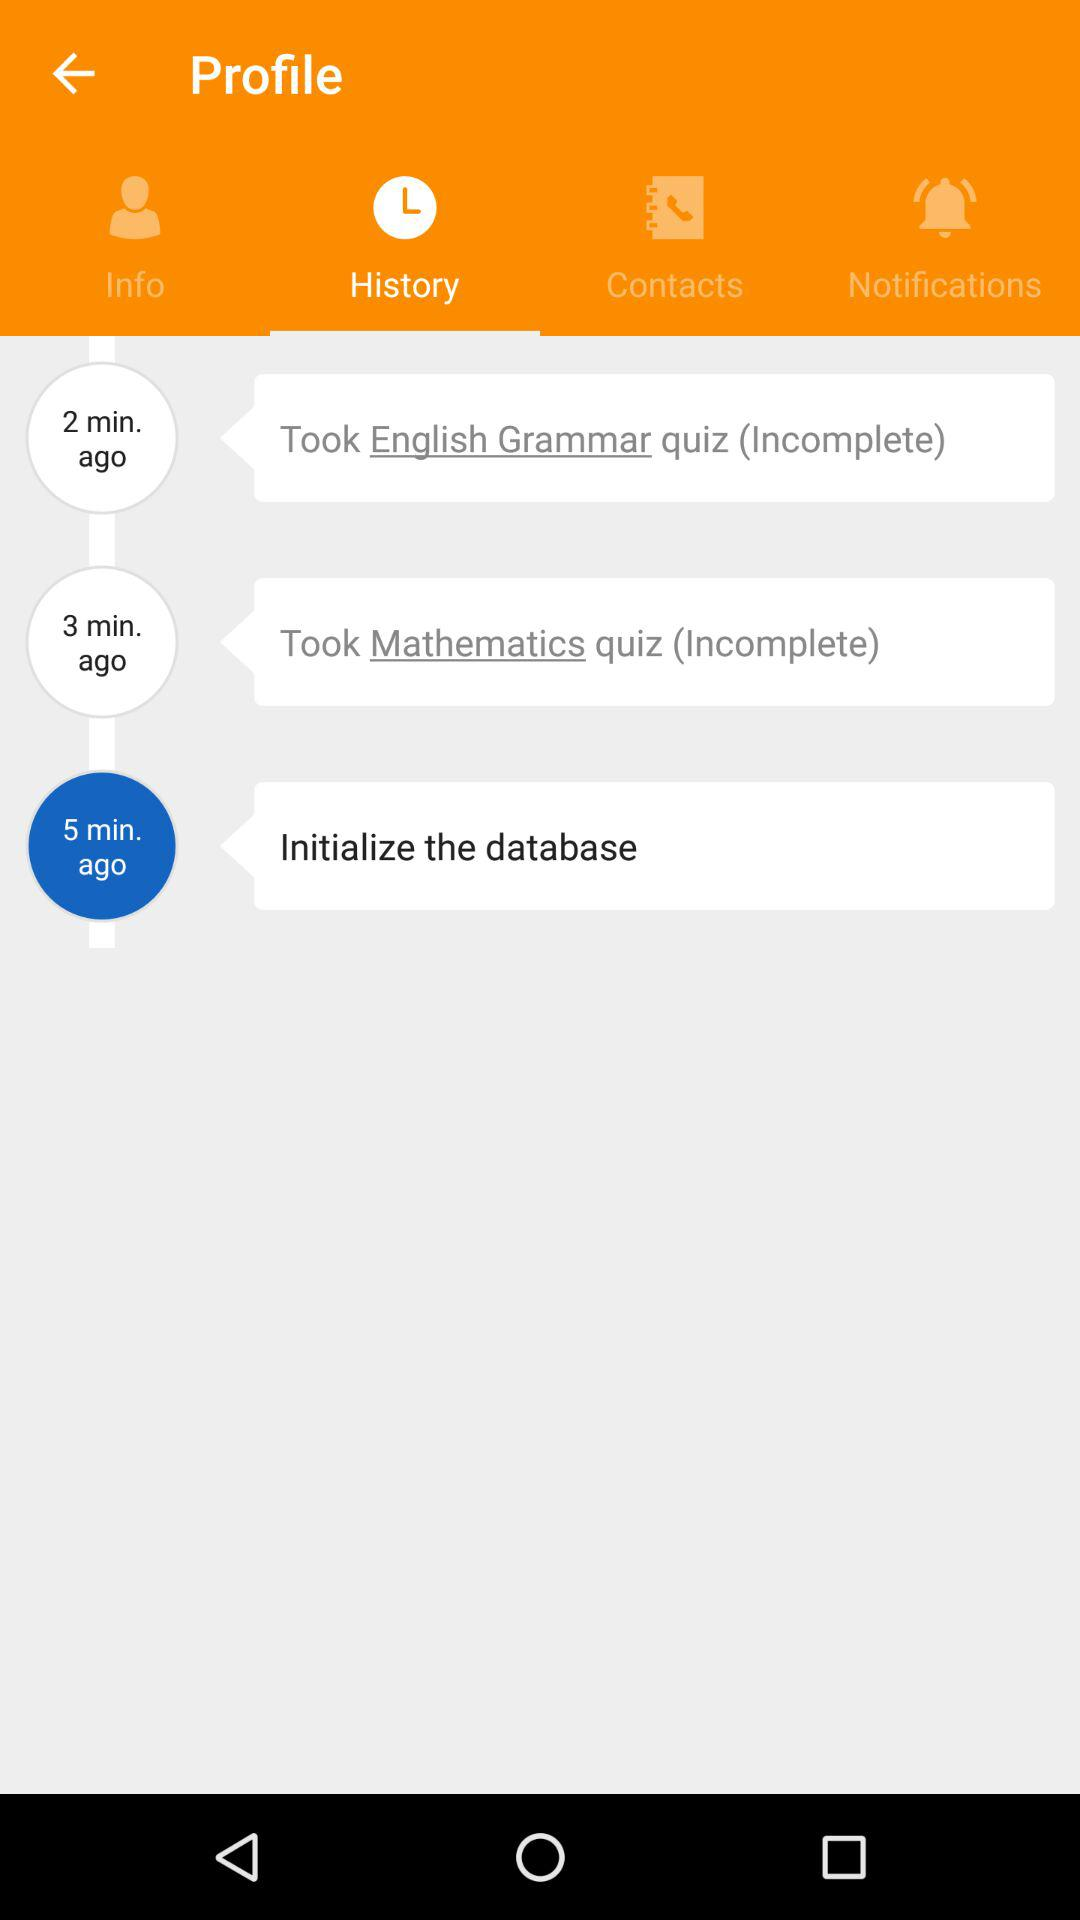How long ago was the "Mathematics" quiz taken? The "Mathematics" quiz was taken 3 minutes ago. 